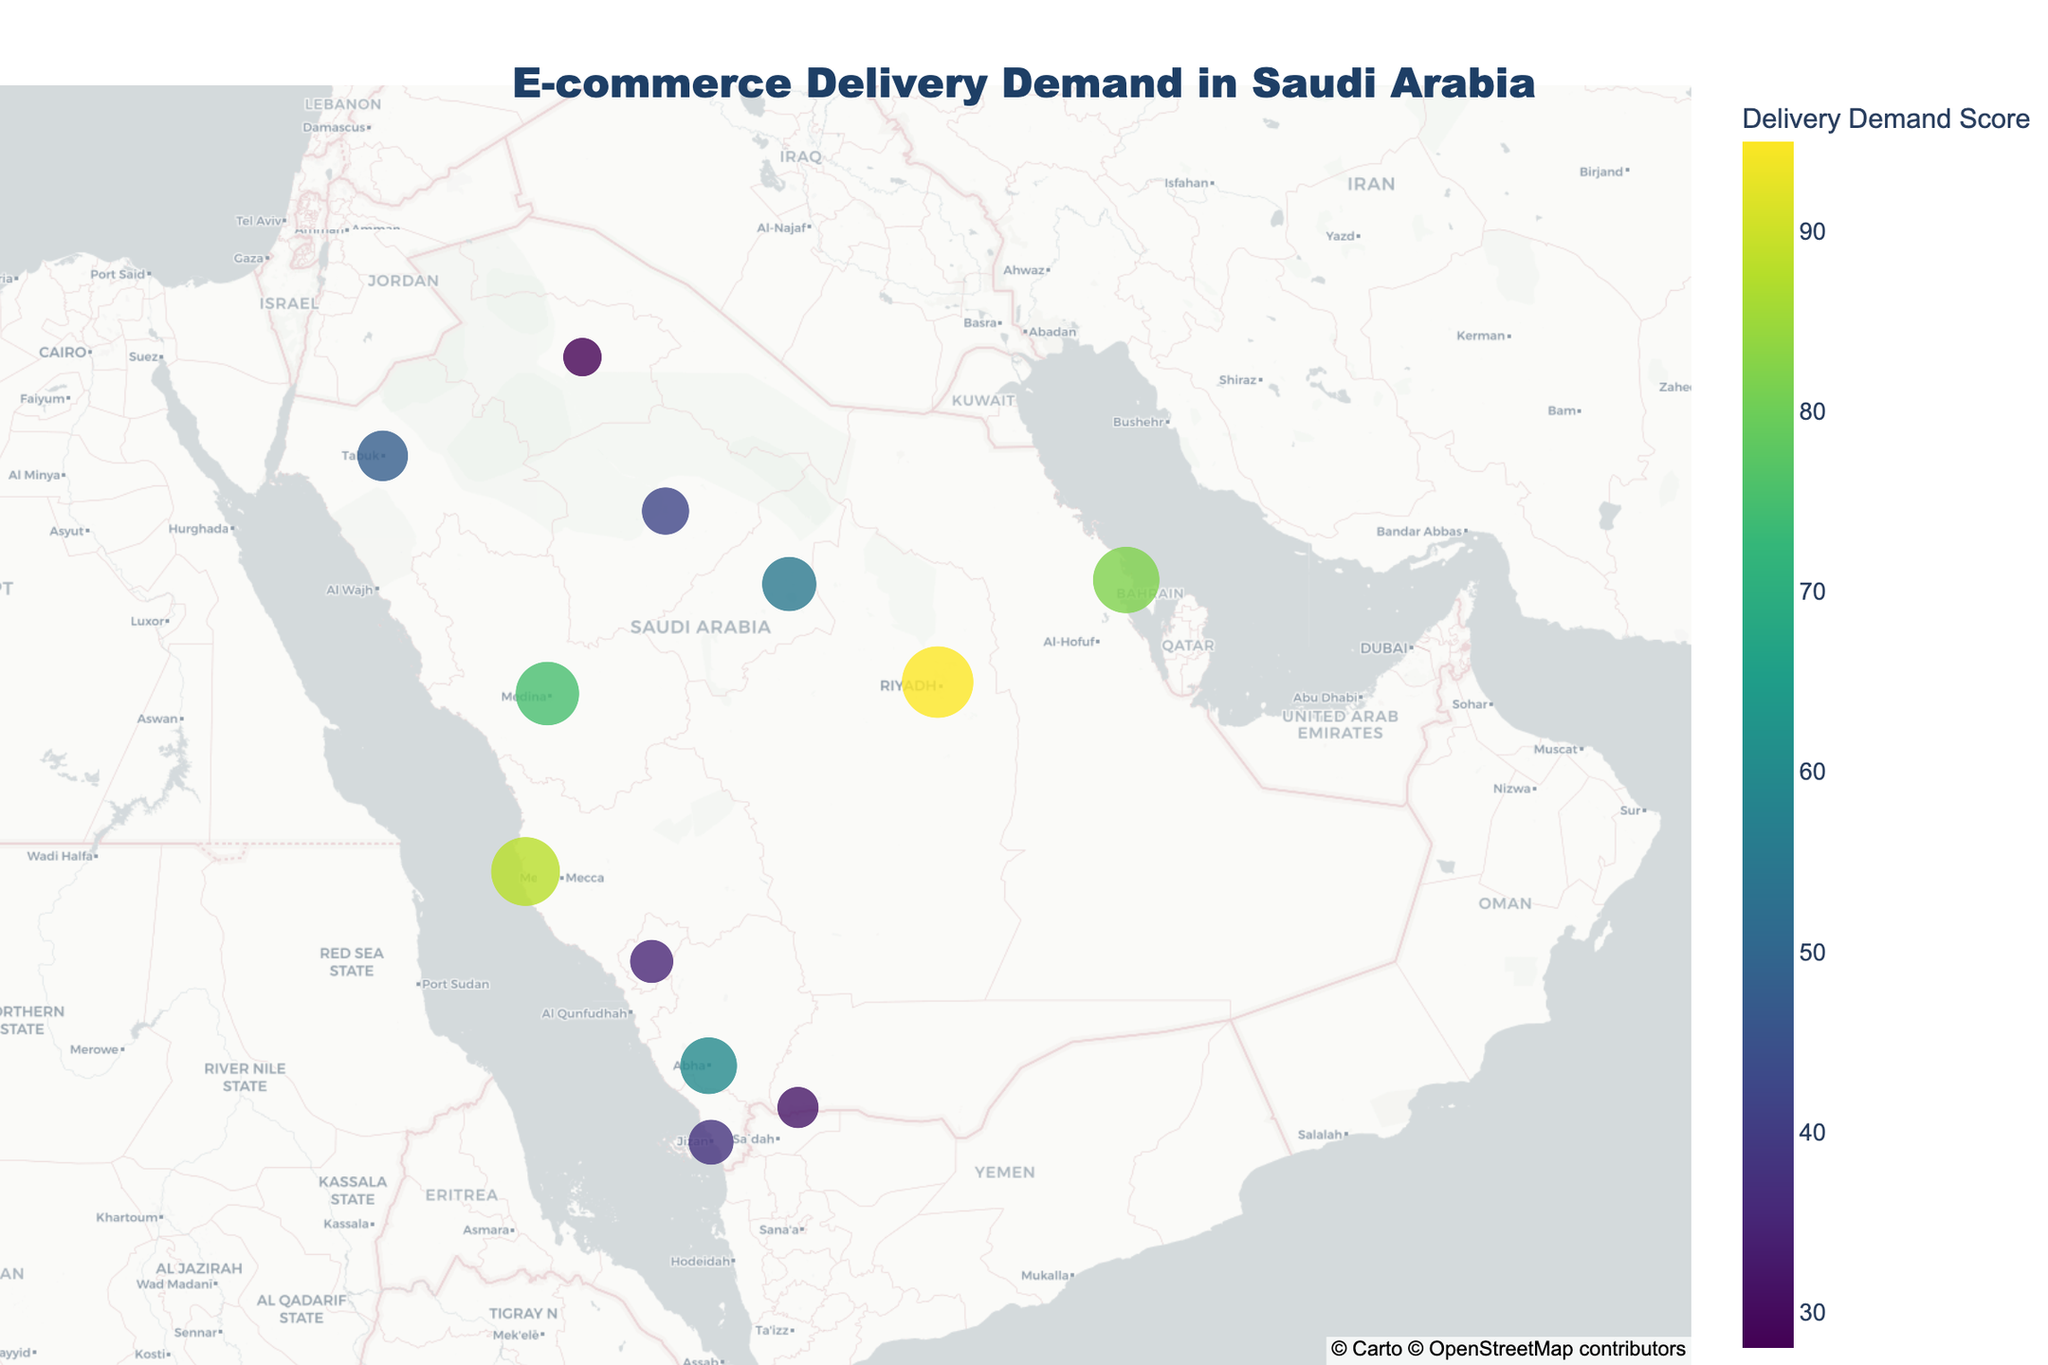How many cities are shown in the map? By counting the number of cities listed in the provided data, we can see there are 12 cities in the geographic plot.
Answer: 12 Which city has the highest delivery demand score? Referring to the plot, Riyadh has the largest marker and the highest color intensity, indicating it has the highest delivery demand score.
Answer: Riyadh What is the average delivery demand score across all cities? Sum all the delivery demand scores (95+88+82+75+60+55+48+42+38+35+32+28=678) and divide by the number of cities (12), so the average is 678/12.
Answer: 56.5 Compare the delivery demand scores of Jeddah and Dammam. Which one is higher? By looking at the plot, Jeddah has a delivery demand score of 88, and Dammam has a score of 82. Therefore, Jeddah has a higher score than Dammam.
Answer: Jeddah Which region has the lowest delivery demand score and what is the score? In the plot, Sakaka in the Al-Jawf region has the smallest marker and the least color intensity, indicating the lowest score of 28.
Answer: Al-Jawf, 28 What is the total delivery demand score for the Central region cities (Riyadh and Buraidah)? Summing up the scores of Riyadh (95) and Buraidah (55), the total delivery demand score for the Central region is 95+55.
Answer: 150 Calculate the difference in delivery demand score between Riyadh and Sakaka. Riyadh has a score of 95 and Sakaka has a score of 28. The difference between them is 95 - 28.
Answer: 67 Identify the city with the median delivery demand score and provide the score. To find the median, list the scores in ascending order: (28, 32, 35, 38, 42, 48, 55, 60, 75, 82, 88, 95). The median value, being the average of the 6th and 7th values (48+55)/2, is 51.5, but since we need the city with score closest to this, Ha'il with score 42 can be considered approximate due to the small dataset.
Answer: Ha'il, 42 Which city in the Western region (Makkah and Madinah) has a higher delivery demand score? Comparing the scores of Jeddah in Makkah (88) and Medina in Madinah (75), Jeddah has a higher delivery demand score.
Answer: Jeddah 